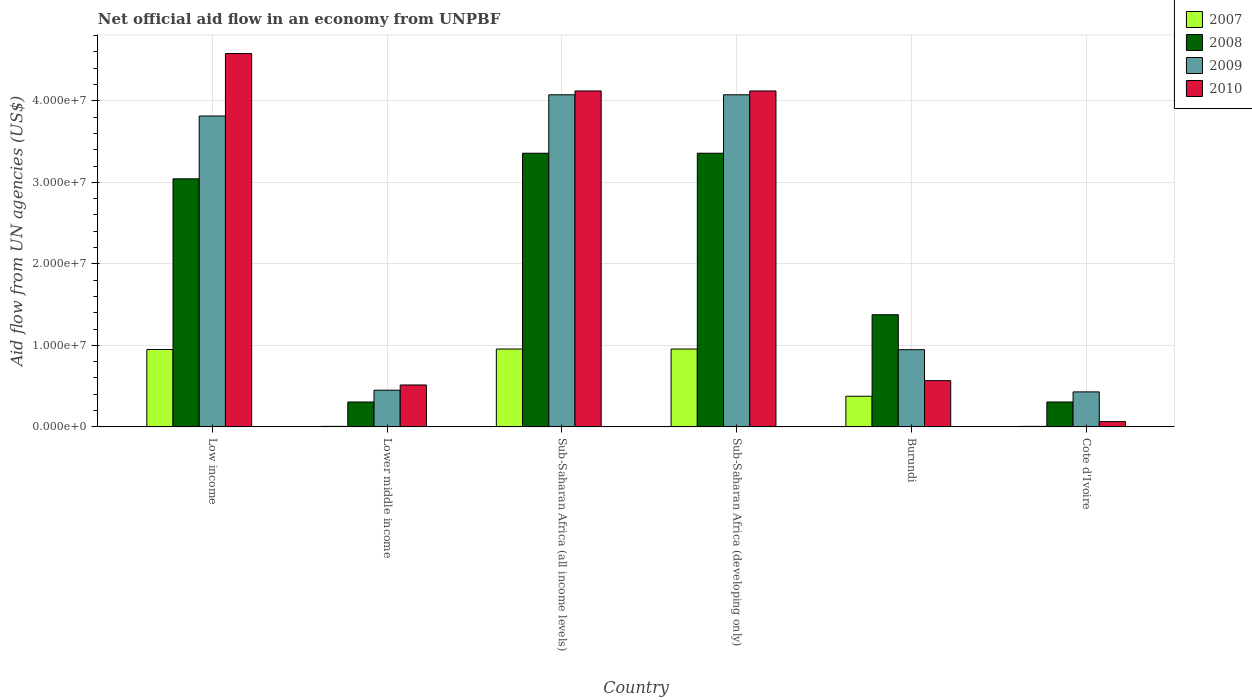How many different coloured bars are there?
Your response must be concise. 4. How many groups of bars are there?
Offer a terse response. 6. What is the label of the 4th group of bars from the left?
Ensure brevity in your answer.  Sub-Saharan Africa (developing only). In how many cases, is the number of bars for a given country not equal to the number of legend labels?
Ensure brevity in your answer.  0. What is the net official aid flow in 2009 in Cote d'Ivoire?
Provide a short and direct response. 4.29e+06. Across all countries, what is the maximum net official aid flow in 2010?
Provide a short and direct response. 4.58e+07. In which country was the net official aid flow in 2009 maximum?
Your answer should be compact. Sub-Saharan Africa (all income levels). In which country was the net official aid flow in 2010 minimum?
Give a very brief answer. Cote d'Ivoire. What is the total net official aid flow in 2010 in the graph?
Your response must be concise. 1.40e+08. What is the difference between the net official aid flow in 2010 in Burundi and that in Sub-Saharan Africa (developing only)?
Keep it short and to the point. -3.55e+07. What is the difference between the net official aid flow in 2009 in Low income and the net official aid flow in 2008 in Sub-Saharan Africa (developing only)?
Give a very brief answer. 4.57e+06. What is the average net official aid flow in 2008 per country?
Make the answer very short. 1.96e+07. What is the difference between the net official aid flow of/in 2008 and net official aid flow of/in 2009 in Cote d'Ivoire?
Make the answer very short. -1.24e+06. In how many countries, is the net official aid flow in 2009 greater than 22000000 US$?
Provide a short and direct response. 3. What is the ratio of the net official aid flow in 2010 in Burundi to that in Sub-Saharan Africa (developing only)?
Your answer should be very brief. 0.14. Is the net official aid flow in 2010 in Cote d'Ivoire less than that in Sub-Saharan Africa (all income levels)?
Give a very brief answer. Yes. What is the difference between the highest and the second highest net official aid flow in 2009?
Offer a very short reply. 2.60e+06. What is the difference between the highest and the lowest net official aid flow in 2009?
Make the answer very short. 3.64e+07. Is the sum of the net official aid flow in 2009 in Low income and Sub-Saharan Africa (developing only) greater than the maximum net official aid flow in 2008 across all countries?
Ensure brevity in your answer.  Yes. What does the 1st bar from the left in Low income represents?
Your response must be concise. 2007. How many bars are there?
Keep it short and to the point. 24. What is the difference between two consecutive major ticks on the Y-axis?
Provide a succinct answer. 1.00e+07. Does the graph contain any zero values?
Your answer should be compact. No. Where does the legend appear in the graph?
Your answer should be compact. Top right. How are the legend labels stacked?
Give a very brief answer. Vertical. What is the title of the graph?
Ensure brevity in your answer.  Net official aid flow in an economy from UNPBF. Does "1962" appear as one of the legend labels in the graph?
Your answer should be compact. No. What is the label or title of the X-axis?
Keep it short and to the point. Country. What is the label or title of the Y-axis?
Make the answer very short. Aid flow from UN agencies (US$). What is the Aid flow from UN agencies (US$) in 2007 in Low income?
Give a very brief answer. 9.49e+06. What is the Aid flow from UN agencies (US$) of 2008 in Low income?
Make the answer very short. 3.04e+07. What is the Aid flow from UN agencies (US$) in 2009 in Low income?
Ensure brevity in your answer.  3.81e+07. What is the Aid flow from UN agencies (US$) of 2010 in Low income?
Provide a short and direct response. 4.58e+07. What is the Aid flow from UN agencies (US$) in 2008 in Lower middle income?
Provide a succinct answer. 3.05e+06. What is the Aid flow from UN agencies (US$) in 2009 in Lower middle income?
Your answer should be very brief. 4.50e+06. What is the Aid flow from UN agencies (US$) of 2010 in Lower middle income?
Give a very brief answer. 5.14e+06. What is the Aid flow from UN agencies (US$) in 2007 in Sub-Saharan Africa (all income levels)?
Offer a terse response. 9.55e+06. What is the Aid flow from UN agencies (US$) in 2008 in Sub-Saharan Africa (all income levels)?
Provide a short and direct response. 3.36e+07. What is the Aid flow from UN agencies (US$) of 2009 in Sub-Saharan Africa (all income levels)?
Offer a terse response. 4.07e+07. What is the Aid flow from UN agencies (US$) in 2010 in Sub-Saharan Africa (all income levels)?
Your answer should be compact. 4.12e+07. What is the Aid flow from UN agencies (US$) in 2007 in Sub-Saharan Africa (developing only)?
Keep it short and to the point. 9.55e+06. What is the Aid flow from UN agencies (US$) of 2008 in Sub-Saharan Africa (developing only)?
Your answer should be compact. 3.36e+07. What is the Aid flow from UN agencies (US$) in 2009 in Sub-Saharan Africa (developing only)?
Your response must be concise. 4.07e+07. What is the Aid flow from UN agencies (US$) of 2010 in Sub-Saharan Africa (developing only)?
Your answer should be very brief. 4.12e+07. What is the Aid flow from UN agencies (US$) in 2007 in Burundi?
Offer a terse response. 3.76e+06. What is the Aid flow from UN agencies (US$) of 2008 in Burundi?
Make the answer very short. 1.38e+07. What is the Aid flow from UN agencies (US$) of 2009 in Burundi?
Provide a short and direct response. 9.47e+06. What is the Aid flow from UN agencies (US$) of 2010 in Burundi?
Offer a terse response. 5.67e+06. What is the Aid flow from UN agencies (US$) in 2008 in Cote d'Ivoire?
Provide a short and direct response. 3.05e+06. What is the Aid flow from UN agencies (US$) of 2009 in Cote d'Ivoire?
Make the answer very short. 4.29e+06. What is the Aid flow from UN agencies (US$) of 2010 in Cote d'Ivoire?
Provide a succinct answer. 6.50e+05. Across all countries, what is the maximum Aid flow from UN agencies (US$) of 2007?
Ensure brevity in your answer.  9.55e+06. Across all countries, what is the maximum Aid flow from UN agencies (US$) in 2008?
Provide a succinct answer. 3.36e+07. Across all countries, what is the maximum Aid flow from UN agencies (US$) in 2009?
Make the answer very short. 4.07e+07. Across all countries, what is the maximum Aid flow from UN agencies (US$) of 2010?
Provide a short and direct response. 4.58e+07. Across all countries, what is the minimum Aid flow from UN agencies (US$) of 2007?
Offer a terse response. 6.00e+04. Across all countries, what is the minimum Aid flow from UN agencies (US$) in 2008?
Offer a terse response. 3.05e+06. Across all countries, what is the minimum Aid flow from UN agencies (US$) of 2009?
Give a very brief answer. 4.29e+06. Across all countries, what is the minimum Aid flow from UN agencies (US$) in 2010?
Ensure brevity in your answer.  6.50e+05. What is the total Aid flow from UN agencies (US$) in 2007 in the graph?
Your response must be concise. 3.25e+07. What is the total Aid flow from UN agencies (US$) in 2008 in the graph?
Provide a short and direct response. 1.17e+08. What is the total Aid flow from UN agencies (US$) of 2009 in the graph?
Your answer should be very brief. 1.38e+08. What is the total Aid flow from UN agencies (US$) in 2010 in the graph?
Keep it short and to the point. 1.40e+08. What is the difference between the Aid flow from UN agencies (US$) of 2007 in Low income and that in Lower middle income?
Make the answer very short. 9.43e+06. What is the difference between the Aid flow from UN agencies (US$) of 2008 in Low income and that in Lower middle income?
Provide a short and direct response. 2.74e+07. What is the difference between the Aid flow from UN agencies (US$) in 2009 in Low income and that in Lower middle income?
Your answer should be compact. 3.36e+07. What is the difference between the Aid flow from UN agencies (US$) in 2010 in Low income and that in Lower middle income?
Provide a succinct answer. 4.07e+07. What is the difference between the Aid flow from UN agencies (US$) of 2008 in Low income and that in Sub-Saharan Africa (all income levels)?
Give a very brief answer. -3.14e+06. What is the difference between the Aid flow from UN agencies (US$) in 2009 in Low income and that in Sub-Saharan Africa (all income levels)?
Your answer should be very brief. -2.60e+06. What is the difference between the Aid flow from UN agencies (US$) of 2010 in Low income and that in Sub-Saharan Africa (all income levels)?
Provide a succinct answer. 4.59e+06. What is the difference between the Aid flow from UN agencies (US$) in 2008 in Low income and that in Sub-Saharan Africa (developing only)?
Make the answer very short. -3.14e+06. What is the difference between the Aid flow from UN agencies (US$) of 2009 in Low income and that in Sub-Saharan Africa (developing only)?
Provide a succinct answer. -2.60e+06. What is the difference between the Aid flow from UN agencies (US$) of 2010 in Low income and that in Sub-Saharan Africa (developing only)?
Keep it short and to the point. 4.59e+06. What is the difference between the Aid flow from UN agencies (US$) of 2007 in Low income and that in Burundi?
Your answer should be very brief. 5.73e+06. What is the difference between the Aid flow from UN agencies (US$) in 2008 in Low income and that in Burundi?
Your answer should be compact. 1.67e+07. What is the difference between the Aid flow from UN agencies (US$) of 2009 in Low income and that in Burundi?
Your answer should be compact. 2.87e+07. What is the difference between the Aid flow from UN agencies (US$) in 2010 in Low income and that in Burundi?
Offer a very short reply. 4.01e+07. What is the difference between the Aid flow from UN agencies (US$) of 2007 in Low income and that in Cote d'Ivoire?
Offer a very short reply. 9.43e+06. What is the difference between the Aid flow from UN agencies (US$) of 2008 in Low income and that in Cote d'Ivoire?
Ensure brevity in your answer.  2.74e+07. What is the difference between the Aid flow from UN agencies (US$) in 2009 in Low income and that in Cote d'Ivoire?
Your answer should be very brief. 3.38e+07. What is the difference between the Aid flow from UN agencies (US$) of 2010 in Low income and that in Cote d'Ivoire?
Make the answer very short. 4.52e+07. What is the difference between the Aid flow from UN agencies (US$) in 2007 in Lower middle income and that in Sub-Saharan Africa (all income levels)?
Offer a very short reply. -9.49e+06. What is the difference between the Aid flow from UN agencies (US$) in 2008 in Lower middle income and that in Sub-Saharan Africa (all income levels)?
Your answer should be compact. -3.05e+07. What is the difference between the Aid flow from UN agencies (US$) in 2009 in Lower middle income and that in Sub-Saharan Africa (all income levels)?
Keep it short and to the point. -3.62e+07. What is the difference between the Aid flow from UN agencies (US$) in 2010 in Lower middle income and that in Sub-Saharan Africa (all income levels)?
Offer a terse response. -3.61e+07. What is the difference between the Aid flow from UN agencies (US$) of 2007 in Lower middle income and that in Sub-Saharan Africa (developing only)?
Keep it short and to the point. -9.49e+06. What is the difference between the Aid flow from UN agencies (US$) in 2008 in Lower middle income and that in Sub-Saharan Africa (developing only)?
Give a very brief answer. -3.05e+07. What is the difference between the Aid flow from UN agencies (US$) of 2009 in Lower middle income and that in Sub-Saharan Africa (developing only)?
Offer a terse response. -3.62e+07. What is the difference between the Aid flow from UN agencies (US$) of 2010 in Lower middle income and that in Sub-Saharan Africa (developing only)?
Provide a short and direct response. -3.61e+07. What is the difference between the Aid flow from UN agencies (US$) of 2007 in Lower middle income and that in Burundi?
Provide a succinct answer. -3.70e+06. What is the difference between the Aid flow from UN agencies (US$) of 2008 in Lower middle income and that in Burundi?
Provide a short and direct response. -1.07e+07. What is the difference between the Aid flow from UN agencies (US$) in 2009 in Lower middle income and that in Burundi?
Make the answer very short. -4.97e+06. What is the difference between the Aid flow from UN agencies (US$) in 2010 in Lower middle income and that in Burundi?
Provide a short and direct response. -5.30e+05. What is the difference between the Aid flow from UN agencies (US$) of 2008 in Lower middle income and that in Cote d'Ivoire?
Make the answer very short. 0. What is the difference between the Aid flow from UN agencies (US$) in 2009 in Lower middle income and that in Cote d'Ivoire?
Provide a succinct answer. 2.10e+05. What is the difference between the Aid flow from UN agencies (US$) in 2010 in Lower middle income and that in Cote d'Ivoire?
Your answer should be compact. 4.49e+06. What is the difference between the Aid flow from UN agencies (US$) of 2007 in Sub-Saharan Africa (all income levels) and that in Sub-Saharan Africa (developing only)?
Offer a very short reply. 0. What is the difference between the Aid flow from UN agencies (US$) in 2008 in Sub-Saharan Africa (all income levels) and that in Sub-Saharan Africa (developing only)?
Offer a terse response. 0. What is the difference between the Aid flow from UN agencies (US$) in 2007 in Sub-Saharan Africa (all income levels) and that in Burundi?
Offer a very short reply. 5.79e+06. What is the difference between the Aid flow from UN agencies (US$) of 2008 in Sub-Saharan Africa (all income levels) and that in Burundi?
Keep it short and to the point. 1.98e+07. What is the difference between the Aid flow from UN agencies (US$) in 2009 in Sub-Saharan Africa (all income levels) and that in Burundi?
Offer a very short reply. 3.13e+07. What is the difference between the Aid flow from UN agencies (US$) of 2010 in Sub-Saharan Africa (all income levels) and that in Burundi?
Your response must be concise. 3.55e+07. What is the difference between the Aid flow from UN agencies (US$) in 2007 in Sub-Saharan Africa (all income levels) and that in Cote d'Ivoire?
Ensure brevity in your answer.  9.49e+06. What is the difference between the Aid flow from UN agencies (US$) of 2008 in Sub-Saharan Africa (all income levels) and that in Cote d'Ivoire?
Provide a short and direct response. 3.05e+07. What is the difference between the Aid flow from UN agencies (US$) in 2009 in Sub-Saharan Africa (all income levels) and that in Cote d'Ivoire?
Provide a short and direct response. 3.64e+07. What is the difference between the Aid flow from UN agencies (US$) in 2010 in Sub-Saharan Africa (all income levels) and that in Cote d'Ivoire?
Your answer should be compact. 4.06e+07. What is the difference between the Aid flow from UN agencies (US$) in 2007 in Sub-Saharan Africa (developing only) and that in Burundi?
Make the answer very short. 5.79e+06. What is the difference between the Aid flow from UN agencies (US$) in 2008 in Sub-Saharan Africa (developing only) and that in Burundi?
Ensure brevity in your answer.  1.98e+07. What is the difference between the Aid flow from UN agencies (US$) in 2009 in Sub-Saharan Africa (developing only) and that in Burundi?
Ensure brevity in your answer.  3.13e+07. What is the difference between the Aid flow from UN agencies (US$) of 2010 in Sub-Saharan Africa (developing only) and that in Burundi?
Your response must be concise. 3.55e+07. What is the difference between the Aid flow from UN agencies (US$) of 2007 in Sub-Saharan Africa (developing only) and that in Cote d'Ivoire?
Give a very brief answer. 9.49e+06. What is the difference between the Aid flow from UN agencies (US$) of 2008 in Sub-Saharan Africa (developing only) and that in Cote d'Ivoire?
Your answer should be compact. 3.05e+07. What is the difference between the Aid flow from UN agencies (US$) of 2009 in Sub-Saharan Africa (developing only) and that in Cote d'Ivoire?
Give a very brief answer. 3.64e+07. What is the difference between the Aid flow from UN agencies (US$) of 2010 in Sub-Saharan Africa (developing only) and that in Cote d'Ivoire?
Ensure brevity in your answer.  4.06e+07. What is the difference between the Aid flow from UN agencies (US$) of 2007 in Burundi and that in Cote d'Ivoire?
Your response must be concise. 3.70e+06. What is the difference between the Aid flow from UN agencies (US$) of 2008 in Burundi and that in Cote d'Ivoire?
Offer a terse response. 1.07e+07. What is the difference between the Aid flow from UN agencies (US$) in 2009 in Burundi and that in Cote d'Ivoire?
Give a very brief answer. 5.18e+06. What is the difference between the Aid flow from UN agencies (US$) in 2010 in Burundi and that in Cote d'Ivoire?
Give a very brief answer. 5.02e+06. What is the difference between the Aid flow from UN agencies (US$) of 2007 in Low income and the Aid flow from UN agencies (US$) of 2008 in Lower middle income?
Provide a short and direct response. 6.44e+06. What is the difference between the Aid flow from UN agencies (US$) in 2007 in Low income and the Aid flow from UN agencies (US$) in 2009 in Lower middle income?
Ensure brevity in your answer.  4.99e+06. What is the difference between the Aid flow from UN agencies (US$) of 2007 in Low income and the Aid flow from UN agencies (US$) of 2010 in Lower middle income?
Your response must be concise. 4.35e+06. What is the difference between the Aid flow from UN agencies (US$) in 2008 in Low income and the Aid flow from UN agencies (US$) in 2009 in Lower middle income?
Your answer should be very brief. 2.59e+07. What is the difference between the Aid flow from UN agencies (US$) of 2008 in Low income and the Aid flow from UN agencies (US$) of 2010 in Lower middle income?
Keep it short and to the point. 2.53e+07. What is the difference between the Aid flow from UN agencies (US$) in 2009 in Low income and the Aid flow from UN agencies (US$) in 2010 in Lower middle income?
Offer a terse response. 3.30e+07. What is the difference between the Aid flow from UN agencies (US$) of 2007 in Low income and the Aid flow from UN agencies (US$) of 2008 in Sub-Saharan Africa (all income levels)?
Offer a terse response. -2.41e+07. What is the difference between the Aid flow from UN agencies (US$) of 2007 in Low income and the Aid flow from UN agencies (US$) of 2009 in Sub-Saharan Africa (all income levels)?
Your response must be concise. -3.12e+07. What is the difference between the Aid flow from UN agencies (US$) of 2007 in Low income and the Aid flow from UN agencies (US$) of 2010 in Sub-Saharan Africa (all income levels)?
Your answer should be very brief. -3.17e+07. What is the difference between the Aid flow from UN agencies (US$) in 2008 in Low income and the Aid flow from UN agencies (US$) in 2009 in Sub-Saharan Africa (all income levels)?
Provide a short and direct response. -1.03e+07. What is the difference between the Aid flow from UN agencies (US$) of 2008 in Low income and the Aid flow from UN agencies (US$) of 2010 in Sub-Saharan Africa (all income levels)?
Offer a very short reply. -1.08e+07. What is the difference between the Aid flow from UN agencies (US$) of 2009 in Low income and the Aid flow from UN agencies (US$) of 2010 in Sub-Saharan Africa (all income levels)?
Keep it short and to the point. -3.07e+06. What is the difference between the Aid flow from UN agencies (US$) of 2007 in Low income and the Aid flow from UN agencies (US$) of 2008 in Sub-Saharan Africa (developing only)?
Ensure brevity in your answer.  -2.41e+07. What is the difference between the Aid flow from UN agencies (US$) of 2007 in Low income and the Aid flow from UN agencies (US$) of 2009 in Sub-Saharan Africa (developing only)?
Provide a short and direct response. -3.12e+07. What is the difference between the Aid flow from UN agencies (US$) of 2007 in Low income and the Aid flow from UN agencies (US$) of 2010 in Sub-Saharan Africa (developing only)?
Offer a terse response. -3.17e+07. What is the difference between the Aid flow from UN agencies (US$) of 2008 in Low income and the Aid flow from UN agencies (US$) of 2009 in Sub-Saharan Africa (developing only)?
Your response must be concise. -1.03e+07. What is the difference between the Aid flow from UN agencies (US$) of 2008 in Low income and the Aid flow from UN agencies (US$) of 2010 in Sub-Saharan Africa (developing only)?
Your answer should be compact. -1.08e+07. What is the difference between the Aid flow from UN agencies (US$) in 2009 in Low income and the Aid flow from UN agencies (US$) in 2010 in Sub-Saharan Africa (developing only)?
Offer a very short reply. -3.07e+06. What is the difference between the Aid flow from UN agencies (US$) in 2007 in Low income and the Aid flow from UN agencies (US$) in 2008 in Burundi?
Offer a terse response. -4.27e+06. What is the difference between the Aid flow from UN agencies (US$) of 2007 in Low income and the Aid flow from UN agencies (US$) of 2009 in Burundi?
Provide a succinct answer. 2.00e+04. What is the difference between the Aid flow from UN agencies (US$) of 2007 in Low income and the Aid flow from UN agencies (US$) of 2010 in Burundi?
Ensure brevity in your answer.  3.82e+06. What is the difference between the Aid flow from UN agencies (US$) of 2008 in Low income and the Aid flow from UN agencies (US$) of 2009 in Burundi?
Offer a very short reply. 2.10e+07. What is the difference between the Aid flow from UN agencies (US$) of 2008 in Low income and the Aid flow from UN agencies (US$) of 2010 in Burundi?
Your response must be concise. 2.48e+07. What is the difference between the Aid flow from UN agencies (US$) in 2009 in Low income and the Aid flow from UN agencies (US$) in 2010 in Burundi?
Make the answer very short. 3.25e+07. What is the difference between the Aid flow from UN agencies (US$) of 2007 in Low income and the Aid flow from UN agencies (US$) of 2008 in Cote d'Ivoire?
Keep it short and to the point. 6.44e+06. What is the difference between the Aid flow from UN agencies (US$) in 2007 in Low income and the Aid flow from UN agencies (US$) in 2009 in Cote d'Ivoire?
Your response must be concise. 5.20e+06. What is the difference between the Aid flow from UN agencies (US$) in 2007 in Low income and the Aid flow from UN agencies (US$) in 2010 in Cote d'Ivoire?
Offer a terse response. 8.84e+06. What is the difference between the Aid flow from UN agencies (US$) of 2008 in Low income and the Aid flow from UN agencies (US$) of 2009 in Cote d'Ivoire?
Offer a terse response. 2.61e+07. What is the difference between the Aid flow from UN agencies (US$) in 2008 in Low income and the Aid flow from UN agencies (US$) in 2010 in Cote d'Ivoire?
Ensure brevity in your answer.  2.98e+07. What is the difference between the Aid flow from UN agencies (US$) of 2009 in Low income and the Aid flow from UN agencies (US$) of 2010 in Cote d'Ivoire?
Give a very brief answer. 3.75e+07. What is the difference between the Aid flow from UN agencies (US$) in 2007 in Lower middle income and the Aid flow from UN agencies (US$) in 2008 in Sub-Saharan Africa (all income levels)?
Your response must be concise. -3.35e+07. What is the difference between the Aid flow from UN agencies (US$) of 2007 in Lower middle income and the Aid flow from UN agencies (US$) of 2009 in Sub-Saharan Africa (all income levels)?
Give a very brief answer. -4.07e+07. What is the difference between the Aid flow from UN agencies (US$) in 2007 in Lower middle income and the Aid flow from UN agencies (US$) in 2010 in Sub-Saharan Africa (all income levels)?
Provide a succinct answer. -4.12e+07. What is the difference between the Aid flow from UN agencies (US$) in 2008 in Lower middle income and the Aid flow from UN agencies (US$) in 2009 in Sub-Saharan Africa (all income levels)?
Your response must be concise. -3.77e+07. What is the difference between the Aid flow from UN agencies (US$) in 2008 in Lower middle income and the Aid flow from UN agencies (US$) in 2010 in Sub-Saharan Africa (all income levels)?
Your answer should be very brief. -3.82e+07. What is the difference between the Aid flow from UN agencies (US$) of 2009 in Lower middle income and the Aid flow from UN agencies (US$) of 2010 in Sub-Saharan Africa (all income levels)?
Keep it short and to the point. -3.67e+07. What is the difference between the Aid flow from UN agencies (US$) in 2007 in Lower middle income and the Aid flow from UN agencies (US$) in 2008 in Sub-Saharan Africa (developing only)?
Keep it short and to the point. -3.35e+07. What is the difference between the Aid flow from UN agencies (US$) of 2007 in Lower middle income and the Aid flow from UN agencies (US$) of 2009 in Sub-Saharan Africa (developing only)?
Offer a terse response. -4.07e+07. What is the difference between the Aid flow from UN agencies (US$) in 2007 in Lower middle income and the Aid flow from UN agencies (US$) in 2010 in Sub-Saharan Africa (developing only)?
Provide a succinct answer. -4.12e+07. What is the difference between the Aid flow from UN agencies (US$) of 2008 in Lower middle income and the Aid flow from UN agencies (US$) of 2009 in Sub-Saharan Africa (developing only)?
Provide a short and direct response. -3.77e+07. What is the difference between the Aid flow from UN agencies (US$) of 2008 in Lower middle income and the Aid flow from UN agencies (US$) of 2010 in Sub-Saharan Africa (developing only)?
Give a very brief answer. -3.82e+07. What is the difference between the Aid flow from UN agencies (US$) in 2009 in Lower middle income and the Aid flow from UN agencies (US$) in 2010 in Sub-Saharan Africa (developing only)?
Ensure brevity in your answer.  -3.67e+07. What is the difference between the Aid flow from UN agencies (US$) in 2007 in Lower middle income and the Aid flow from UN agencies (US$) in 2008 in Burundi?
Your response must be concise. -1.37e+07. What is the difference between the Aid flow from UN agencies (US$) of 2007 in Lower middle income and the Aid flow from UN agencies (US$) of 2009 in Burundi?
Your answer should be compact. -9.41e+06. What is the difference between the Aid flow from UN agencies (US$) in 2007 in Lower middle income and the Aid flow from UN agencies (US$) in 2010 in Burundi?
Keep it short and to the point. -5.61e+06. What is the difference between the Aid flow from UN agencies (US$) in 2008 in Lower middle income and the Aid flow from UN agencies (US$) in 2009 in Burundi?
Offer a terse response. -6.42e+06. What is the difference between the Aid flow from UN agencies (US$) of 2008 in Lower middle income and the Aid flow from UN agencies (US$) of 2010 in Burundi?
Provide a succinct answer. -2.62e+06. What is the difference between the Aid flow from UN agencies (US$) of 2009 in Lower middle income and the Aid flow from UN agencies (US$) of 2010 in Burundi?
Make the answer very short. -1.17e+06. What is the difference between the Aid flow from UN agencies (US$) of 2007 in Lower middle income and the Aid flow from UN agencies (US$) of 2008 in Cote d'Ivoire?
Your response must be concise. -2.99e+06. What is the difference between the Aid flow from UN agencies (US$) in 2007 in Lower middle income and the Aid flow from UN agencies (US$) in 2009 in Cote d'Ivoire?
Provide a short and direct response. -4.23e+06. What is the difference between the Aid flow from UN agencies (US$) of 2007 in Lower middle income and the Aid flow from UN agencies (US$) of 2010 in Cote d'Ivoire?
Keep it short and to the point. -5.90e+05. What is the difference between the Aid flow from UN agencies (US$) of 2008 in Lower middle income and the Aid flow from UN agencies (US$) of 2009 in Cote d'Ivoire?
Give a very brief answer. -1.24e+06. What is the difference between the Aid flow from UN agencies (US$) in 2008 in Lower middle income and the Aid flow from UN agencies (US$) in 2010 in Cote d'Ivoire?
Ensure brevity in your answer.  2.40e+06. What is the difference between the Aid flow from UN agencies (US$) in 2009 in Lower middle income and the Aid flow from UN agencies (US$) in 2010 in Cote d'Ivoire?
Ensure brevity in your answer.  3.85e+06. What is the difference between the Aid flow from UN agencies (US$) of 2007 in Sub-Saharan Africa (all income levels) and the Aid flow from UN agencies (US$) of 2008 in Sub-Saharan Africa (developing only)?
Make the answer very short. -2.40e+07. What is the difference between the Aid flow from UN agencies (US$) in 2007 in Sub-Saharan Africa (all income levels) and the Aid flow from UN agencies (US$) in 2009 in Sub-Saharan Africa (developing only)?
Offer a very short reply. -3.12e+07. What is the difference between the Aid flow from UN agencies (US$) of 2007 in Sub-Saharan Africa (all income levels) and the Aid flow from UN agencies (US$) of 2010 in Sub-Saharan Africa (developing only)?
Make the answer very short. -3.17e+07. What is the difference between the Aid flow from UN agencies (US$) of 2008 in Sub-Saharan Africa (all income levels) and the Aid flow from UN agencies (US$) of 2009 in Sub-Saharan Africa (developing only)?
Provide a short and direct response. -7.17e+06. What is the difference between the Aid flow from UN agencies (US$) of 2008 in Sub-Saharan Africa (all income levels) and the Aid flow from UN agencies (US$) of 2010 in Sub-Saharan Africa (developing only)?
Make the answer very short. -7.64e+06. What is the difference between the Aid flow from UN agencies (US$) in 2009 in Sub-Saharan Africa (all income levels) and the Aid flow from UN agencies (US$) in 2010 in Sub-Saharan Africa (developing only)?
Provide a succinct answer. -4.70e+05. What is the difference between the Aid flow from UN agencies (US$) in 2007 in Sub-Saharan Africa (all income levels) and the Aid flow from UN agencies (US$) in 2008 in Burundi?
Your answer should be very brief. -4.21e+06. What is the difference between the Aid flow from UN agencies (US$) of 2007 in Sub-Saharan Africa (all income levels) and the Aid flow from UN agencies (US$) of 2009 in Burundi?
Your answer should be very brief. 8.00e+04. What is the difference between the Aid flow from UN agencies (US$) in 2007 in Sub-Saharan Africa (all income levels) and the Aid flow from UN agencies (US$) in 2010 in Burundi?
Provide a short and direct response. 3.88e+06. What is the difference between the Aid flow from UN agencies (US$) of 2008 in Sub-Saharan Africa (all income levels) and the Aid flow from UN agencies (US$) of 2009 in Burundi?
Your response must be concise. 2.41e+07. What is the difference between the Aid flow from UN agencies (US$) of 2008 in Sub-Saharan Africa (all income levels) and the Aid flow from UN agencies (US$) of 2010 in Burundi?
Keep it short and to the point. 2.79e+07. What is the difference between the Aid flow from UN agencies (US$) in 2009 in Sub-Saharan Africa (all income levels) and the Aid flow from UN agencies (US$) in 2010 in Burundi?
Give a very brief answer. 3.51e+07. What is the difference between the Aid flow from UN agencies (US$) in 2007 in Sub-Saharan Africa (all income levels) and the Aid flow from UN agencies (US$) in 2008 in Cote d'Ivoire?
Offer a terse response. 6.50e+06. What is the difference between the Aid flow from UN agencies (US$) of 2007 in Sub-Saharan Africa (all income levels) and the Aid flow from UN agencies (US$) of 2009 in Cote d'Ivoire?
Give a very brief answer. 5.26e+06. What is the difference between the Aid flow from UN agencies (US$) of 2007 in Sub-Saharan Africa (all income levels) and the Aid flow from UN agencies (US$) of 2010 in Cote d'Ivoire?
Your answer should be compact. 8.90e+06. What is the difference between the Aid flow from UN agencies (US$) of 2008 in Sub-Saharan Africa (all income levels) and the Aid flow from UN agencies (US$) of 2009 in Cote d'Ivoire?
Offer a very short reply. 2.93e+07. What is the difference between the Aid flow from UN agencies (US$) of 2008 in Sub-Saharan Africa (all income levels) and the Aid flow from UN agencies (US$) of 2010 in Cote d'Ivoire?
Offer a very short reply. 3.29e+07. What is the difference between the Aid flow from UN agencies (US$) in 2009 in Sub-Saharan Africa (all income levels) and the Aid flow from UN agencies (US$) in 2010 in Cote d'Ivoire?
Offer a terse response. 4.01e+07. What is the difference between the Aid flow from UN agencies (US$) of 2007 in Sub-Saharan Africa (developing only) and the Aid flow from UN agencies (US$) of 2008 in Burundi?
Provide a short and direct response. -4.21e+06. What is the difference between the Aid flow from UN agencies (US$) of 2007 in Sub-Saharan Africa (developing only) and the Aid flow from UN agencies (US$) of 2009 in Burundi?
Ensure brevity in your answer.  8.00e+04. What is the difference between the Aid flow from UN agencies (US$) of 2007 in Sub-Saharan Africa (developing only) and the Aid flow from UN agencies (US$) of 2010 in Burundi?
Your answer should be compact. 3.88e+06. What is the difference between the Aid flow from UN agencies (US$) in 2008 in Sub-Saharan Africa (developing only) and the Aid flow from UN agencies (US$) in 2009 in Burundi?
Offer a very short reply. 2.41e+07. What is the difference between the Aid flow from UN agencies (US$) in 2008 in Sub-Saharan Africa (developing only) and the Aid flow from UN agencies (US$) in 2010 in Burundi?
Your answer should be very brief. 2.79e+07. What is the difference between the Aid flow from UN agencies (US$) in 2009 in Sub-Saharan Africa (developing only) and the Aid flow from UN agencies (US$) in 2010 in Burundi?
Offer a terse response. 3.51e+07. What is the difference between the Aid flow from UN agencies (US$) in 2007 in Sub-Saharan Africa (developing only) and the Aid flow from UN agencies (US$) in 2008 in Cote d'Ivoire?
Your answer should be very brief. 6.50e+06. What is the difference between the Aid flow from UN agencies (US$) in 2007 in Sub-Saharan Africa (developing only) and the Aid flow from UN agencies (US$) in 2009 in Cote d'Ivoire?
Offer a terse response. 5.26e+06. What is the difference between the Aid flow from UN agencies (US$) in 2007 in Sub-Saharan Africa (developing only) and the Aid flow from UN agencies (US$) in 2010 in Cote d'Ivoire?
Provide a succinct answer. 8.90e+06. What is the difference between the Aid flow from UN agencies (US$) of 2008 in Sub-Saharan Africa (developing only) and the Aid flow from UN agencies (US$) of 2009 in Cote d'Ivoire?
Provide a short and direct response. 2.93e+07. What is the difference between the Aid flow from UN agencies (US$) of 2008 in Sub-Saharan Africa (developing only) and the Aid flow from UN agencies (US$) of 2010 in Cote d'Ivoire?
Keep it short and to the point. 3.29e+07. What is the difference between the Aid flow from UN agencies (US$) of 2009 in Sub-Saharan Africa (developing only) and the Aid flow from UN agencies (US$) of 2010 in Cote d'Ivoire?
Make the answer very short. 4.01e+07. What is the difference between the Aid flow from UN agencies (US$) of 2007 in Burundi and the Aid flow from UN agencies (US$) of 2008 in Cote d'Ivoire?
Provide a succinct answer. 7.10e+05. What is the difference between the Aid flow from UN agencies (US$) in 2007 in Burundi and the Aid flow from UN agencies (US$) in 2009 in Cote d'Ivoire?
Make the answer very short. -5.30e+05. What is the difference between the Aid flow from UN agencies (US$) of 2007 in Burundi and the Aid flow from UN agencies (US$) of 2010 in Cote d'Ivoire?
Your answer should be very brief. 3.11e+06. What is the difference between the Aid flow from UN agencies (US$) in 2008 in Burundi and the Aid flow from UN agencies (US$) in 2009 in Cote d'Ivoire?
Give a very brief answer. 9.47e+06. What is the difference between the Aid flow from UN agencies (US$) in 2008 in Burundi and the Aid flow from UN agencies (US$) in 2010 in Cote d'Ivoire?
Offer a very short reply. 1.31e+07. What is the difference between the Aid flow from UN agencies (US$) in 2009 in Burundi and the Aid flow from UN agencies (US$) in 2010 in Cote d'Ivoire?
Give a very brief answer. 8.82e+06. What is the average Aid flow from UN agencies (US$) of 2007 per country?
Provide a short and direct response. 5.41e+06. What is the average Aid flow from UN agencies (US$) in 2008 per country?
Your answer should be very brief. 1.96e+07. What is the average Aid flow from UN agencies (US$) of 2009 per country?
Give a very brief answer. 2.30e+07. What is the average Aid flow from UN agencies (US$) in 2010 per country?
Ensure brevity in your answer.  2.33e+07. What is the difference between the Aid flow from UN agencies (US$) in 2007 and Aid flow from UN agencies (US$) in 2008 in Low income?
Provide a succinct answer. -2.09e+07. What is the difference between the Aid flow from UN agencies (US$) in 2007 and Aid flow from UN agencies (US$) in 2009 in Low income?
Your answer should be compact. -2.86e+07. What is the difference between the Aid flow from UN agencies (US$) in 2007 and Aid flow from UN agencies (US$) in 2010 in Low income?
Offer a very short reply. -3.63e+07. What is the difference between the Aid flow from UN agencies (US$) in 2008 and Aid flow from UN agencies (US$) in 2009 in Low income?
Provide a succinct answer. -7.71e+06. What is the difference between the Aid flow from UN agencies (US$) of 2008 and Aid flow from UN agencies (US$) of 2010 in Low income?
Keep it short and to the point. -1.54e+07. What is the difference between the Aid flow from UN agencies (US$) in 2009 and Aid flow from UN agencies (US$) in 2010 in Low income?
Offer a very short reply. -7.66e+06. What is the difference between the Aid flow from UN agencies (US$) of 2007 and Aid flow from UN agencies (US$) of 2008 in Lower middle income?
Give a very brief answer. -2.99e+06. What is the difference between the Aid flow from UN agencies (US$) of 2007 and Aid flow from UN agencies (US$) of 2009 in Lower middle income?
Keep it short and to the point. -4.44e+06. What is the difference between the Aid flow from UN agencies (US$) of 2007 and Aid flow from UN agencies (US$) of 2010 in Lower middle income?
Your answer should be very brief. -5.08e+06. What is the difference between the Aid flow from UN agencies (US$) in 2008 and Aid flow from UN agencies (US$) in 2009 in Lower middle income?
Provide a succinct answer. -1.45e+06. What is the difference between the Aid flow from UN agencies (US$) in 2008 and Aid flow from UN agencies (US$) in 2010 in Lower middle income?
Keep it short and to the point. -2.09e+06. What is the difference between the Aid flow from UN agencies (US$) in 2009 and Aid flow from UN agencies (US$) in 2010 in Lower middle income?
Provide a succinct answer. -6.40e+05. What is the difference between the Aid flow from UN agencies (US$) in 2007 and Aid flow from UN agencies (US$) in 2008 in Sub-Saharan Africa (all income levels)?
Offer a terse response. -2.40e+07. What is the difference between the Aid flow from UN agencies (US$) in 2007 and Aid flow from UN agencies (US$) in 2009 in Sub-Saharan Africa (all income levels)?
Offer a terse response. -3.12e+07. What is the difference between the Aid flow from UN agencies (US$) of 2007 and Aid flow from UN agencies (US$) of 2010 in Sub-Saharan Africa (all income levels)?
Make the answer very short. -3.17e+07. What is the difference between the Aid flow from UN agencies (US$) in 2008 and Aid flow from UN agencies (US$) in 2009 in Sub-Saharan Africa (all income levels)?
Your response must be concise. -7.17e+06. What is the difference between the Aid flow from UN agencies (US$) in 2008 and Aid flow from UN agencies (US$) in 2010 in Sub-Saharan Africa (all income levels)?
Keep it short and to the point. -7.64e+06. What is the difference between the Aid flow from UN agencies (US$) in 2009 and Aid flow from UN agencies (US$) in 2010 in Sub-Saharan Africa (all income levels)?
Make the answer very short. -4.70e+05. What is the difference between the Aid flow from UN agencies (US$) of 2007 and Aid flow from UN agencies (US$) of 2008 in Sub-Saharan Africa (developing only)?
Provide a short and direct response. -2.40e+07. What is the difference between the Aid flow from UN agencies (US$) in 2007 and Aid flow from UN agencies (US$) in 2009 in Sub-Saharan Africa (developing only)?
Your response must be concise. -3.12e+07. What is the difference between the Aid flow from UN agencies (US$) in 2007 and Aid flow from UN agencies (US$) in 2010 in Sub-Saharan Africa (developing only)?
Keep it short and to the point. -3.17e+07. What is the difference between the Aid flow from UN agencies (US$) of 2008 and Aid flow from UN agencies (US$) of 2009 in Sub-Saharan Africa (developing only)?
Your response must be concise. -7.17e+06. What is the difference between the Aid flow from UN agencies (US$) of 2008 and Aid flow from UN agencies (US$) of 2010 in Sub-Saharan Africa (developing only)?
Offer a terse response. -7.64e+06. What is the difference between the Aid flow from UN agencies (US$) of 2009 and Aid flow from UN agencies (US$) of 2010 in Sub-Saharan Africa (developing only)?
Provide a short and direct response. -4.70e+05. What is the difference between the Aid flow from UN agencies (US$) of 2007 and Aid flow from UN agencies (US$) of 2008 in Burundi?
Ensure brevity in your answer.  -1.00e+07. What is the difference between the Aid flow from UN agencies (US$) of 2007 and Aid flow from UN agencies (US$) of 2009 in Burundi?
Provide a short and direct response. -5.71e+06. What is the difference between the Aid flow from UN agencies (US$) of 2007 and Aid flow from UN agencies (US$) of 2010 in Burundi?
Provide a succinct answer. -1.91e+06. What is the difference between the Aid flow from UN agencies (US$) of 2008 and Aid flow from UN agencies (US$) of 2009 in Burundi?
Offer a very short reply. 4.29e+06. What is the difference between the Aid flow from UN agencies (US$) in 2008 and Aid flow from UN agencies (US$) in 2010 in Burundi?
Give a very brief answer. 8.09e+06. What is the difference between the Aid flow from UN agencies (US$) in 2009 and Aid flow from UN agencies (US$) in 2010 in Burundi?
Your answer should be compact. 3.80e+06. What is the difference between the Aid flow from UN agencies (US$) in 2007 and Aid flow from UN agencies (US$) in 2008 in Cote d'Ivoire?
Your answer should be very brief. -2.99e+06. What is the difference between the Aid flow from UN agencies (US$) of 2007 and Aid flow from UN agencies (US$) of 2009 in Cote d'Ivoire?
Provide a succinct answer. -4.23e+06. What is the difference between the Aid flow from UN agencies (US$) in 2007 and Aid flow from UN agencies (US$) in 2010 in Cote d'Ivoire?
Keep it short and to the point. -5.90e+05. What is the difference between the Aid flow from UN agencies (US$) of 2008 and Aid flow from UN agencies (US$) of 2009 in Cote d'Ivoire?
Offer a very short reply. -1.24e+06. What is the difference between the Aid flow from UN agencies (US$) of 2008 and Aid flow from UN agencies (US$) of 2010 in Cote d'Ivoire?
Ensure brevity in your answer.  2.40e+06. What is the difference between the Aid flow from UN agencies (US$) of 2009 and Aid flow from UN agencies (US$) of 2010 in Cote d'Ivoire?
Give a very brief answer. 3.64e+06. What is the ratio of the Aid flow from UN agencies (US$) in 2007 in Low income to that in Lower middle income?
Provide a succinct answer. 158.17. What is the ratio of the Aid flow from UN agencies (US$) of 2008 in Low income to that in Lower middle income?
Make the answer very short. 9.98. What is the ratio of the Aid flow from UN agencies (US$) in 2009 in Low income to that in Lower middle income?
Your answer should be very brief. 8.48. What is the ratio of the Aid flow from UN agencies (US$) of 2010 in Low income to that in Lower middle income?
Keep it short and to the point. 8.91. What is the ratio of the Aid flow from UN agencies (US$) of 2008 in Low income to that in Sub-Saharan Africa (all income levels)?
Your response must be concise. 0.91. What is the ratio of the Aid flow from UN agencies (US$) of 2009 in Low income to that in Sub-Saharan Africa (all income levels)?
Ensure brevity in your answer.  0.94. What is the ratio of the Aid flow from UN agencies (US$) in 2010 in Low income to that in Sub-Saharan Africa (all income levels)?
Offer a very short reply. 1.11. What is the ratio of the Aid flow from UN agencies (US$) in 2008 in Low income to that in Sub-Saharan Africa (developing only)?
Offer a terse response. 0.91. What is the ratio of the Aid flow from UN agencies (US$) of 2009 in Low income to that in Sub-Saharan Africa (developing only)?
Make the answer very short. 0.94. What is the ratio of the Aid flow from UN agencies (US$) of 2010 in Low income to that in Sub-Saharan Africa (developing only)?
Offer a terse response. 1.11. What is the ratio of the Aid flow from UN agencies (US$) in 2007 in Low income to that in Burundi?
Your response must be concise. 2.52. What is the ratio of the Aid flow from UN agencies (US$) of 2008 in Low income to that in Burundi?
Provide a short and direct response. 2.21. What is the ratio of the Aid flow from UN agencies (US$) of 2009 in Low income to that in Burundi?
Offer a very short reply. 4.03. What is the ratio of the Aid flow from UN agencies (US$) in 2010 in Low income to that in Burundi?
Your response must be concise. 8.08. What is the ratio of the Aid flow from UN agencies (US$) in 2007 in Low income to that in Cote d'Ivoire?
Your answer should be very brief. 158.17. What is the ratio of the Aid flow from UN agencies (US$) of 2008 in Low income to that in Cote d'Ivoire?
Give a very brief answer. 9.98. What is the ratio of the Aid flow from UN agencies (US$) of 2009 in Low income to that in Cote d'Ivoire?
Offer a very short reply. 8.89. What is the ratio of the Aid flow from UN agencies (US$) of 2010 in Low income to that in Cote d'Ivoire?
Give a very brief answer. 70.46. What is the ratio of the Aid flow from UN agencies (US$) in 2007 in Lower middle income to that in Sub-Saharan Africa (all income levels)?
Ensure brevity in your answer.  0.01. What is the ratio of the Aid flow from UN agencies (US$) of 2008 in Lower middle income to that in Sub-Saharan Africa (all income levels)?
Provide a succinct answer. 0.09. What is the ratio of the Aid flow from UN agencies (US$) of 2009 in Lower middle income to that in Sub-Saharan Africa (all income levels)?
Your answer should be very brief. 0.11. What is the ratio of the Aid flow from UN agencies (US$) in 2010 in Lower middle income to that in Sub-Saharan Africa (all income levels)?
Provide a succinct answer. 0.12. What is the ratio of the Aid flow from UN agencies (US$) of 2007 in Lower middle income to that in Sub-Saharan Africa (developing only)?
Offer a very short reply. 0.01. What is the ratio of the Aid flow from UN agencies (US$) in 2008 in Lower middle income to that in Sub-Saharan Africa (developing only)?
Provide a short and direct response. 0.09. What is the ratio of the Aid flow from UN agencies (US$) in 2009 in Lower middle income to that in Sub-Saharan Africa (developing only)?
Provide a short and direct response. 0.11. What is the ratio of the Aid flow from UN agencies (US$) in 2010 in Lower middle income to that in Sub-Saharan Africa (developing only)?
Provide a short and direct response. 0.12. What is the ratio of the Aid flow from UN agencies (US$) of 2007 in Lower middle income to that in Burundi?
Ensure brevity in your answer.  0.02. What is the ratio of the Aid flow from UN agencies (US$) of 2008 in Lower middle income to that in Burundi?
Ensure brevity in your answer.  0.22. What is the ratio of the Aid flow from UN agencies (US$) in 2009 in Lower middle income to that in Burundi?
Provide a short and direct response. 0.48. What is the ratio of the Aid flow from UN agencies (US$) of 2010 in Lower middle income to that in Burundi?
Keep it short and to the point. 0.91. What is the ratio of the Aid flow from UN agencies (US$) of 2007 in Lower middle income to that in Cote d'Ivoire?
Make the answer very short. 1. What is the ratio of the Aid flow from UN agencies (US$) in 2008 in Lower middle income to that in Cote d'Ivoire?
Make the answer very short. 1. What is the ratio of the Aid flow from UN agencies (US$) in 2009 in Lower middle income to that in Cote d'Ivoire?
Your response must be concise. 1.05. What is the ratio of the Aid flow from UN agencies (US$) of 2010 in Lower middle income to that in Cote d'Ivoire?
Make the answer very short. 7.91. What is the ratio of the Aid flow from UN agencies (US$) in 2008 in Sub-Saharan Africa (all income levels) to that in Sub-Saharan Africa (developing only)?
Your answer should be very brief. 1. What is the ratio of the Aid flow from UN agencies (US$) of 2009 in Sub-Saharan Africa (all income levels) to that in Sub-Saharan Africa (developing only)?
Offer a terse response. 1. What is the ratio of the Aid flow from UN agencies (US$) in 2007 in Sub-Saharan Africa (all income levels) to that in Burundi?
Your answer should be compact. 2.54. What is the ratio of the Aid flow from UN agencies (US$) in 2008 in Sub-Saharan Africa (all income levels) to that in Burundi?
Your answer should be very brief. 2.44. What is the ratio of the Aid flow from UN agencies (US$) in 2009 in Sub-Saharan Africa (all income levels) to that in Burundi?
Your answer should be compact. 4.3. What is the ratio of the Aid flow from UN agencies (US$) of 2010 in Sub-Saharan Africa (all income levels) to that in Burundi?
Provide a short and direct response. 7.27. What is the ratio of the Aid flow from UN agencies (US$) in 2007 in Sub-Saharan Africa (all income levels) to that in Cote d'Ivoire?
Make the answer very short. 159.17. What is the ratio of the Aid flow from UN agencies (US$) of 2008 in Sub-Saharan Africa (all income levels) to that in Cote d'Ivoire?
Keep it short and to the point. 11.01. What is the ratio of the Aid flow from UN agencies (US$) of 2009 in Sub-Saharan Africa (all income levels) to that in Cote d'Ivoire?
Keep it short and to the point. 9.5. What is the ratio of the Aid flow from UN agencies (US$) in 2010 in Sub-Saharan Africa (all income levels) to that in Cote d'Ivoire?
Make the answer very short. 63.4. What is the ratio of the Aid flow from UN agencies (US$) in 2007 in Sub-Saharan Africa (developing only) to that in Burundi?
Ensure brevity in your answer.  2.54. What is the ratio of the Aid flow from UN agencies (US$) in 2008 in Sub-Saharan Africa (developing only) to that in Burundi?
Give a very brief answer. 2.44. What is the ratio of the Aid flow from UN agencies (US$) in 2009 in Sub-Saharan Africa (developing only) to that in Burundi?
Keep it short and to the point. 4.3. What is the ratio of the Aid flow from UN agencies (US$) of 2010 in Sub-Saharan Africa (developing only) to that in Burundi?
Keep it short and to the point. 7.27. What is the ratio of the Aid flow from UN agencies (US$) of 2007 in Sub-Saharan Africa (developing only) to that in Cote d'Ivoire?
Ensure brevity in your answer.  159.17. What is the ratio of the Aid flow from UN agencies (US$) of 2008 in Sub-Saharan Africa (developing only) to that in Cote d'Ivoire?
Provide a short and direct response. 11.01. What is the ratio of the Aid flow from UN agencies (US$) in 2009 in Sub-Saharan Africa (developing only) to that in Cote d'Ivoire?
Your answer should be very brief. 9.5. What is the ratio of the Aid flow from UN agencies (US$) of 2010 in Sub-Saharan Africa (developing only) to that in Cote d'Ivoire?
Offer a terse response. 63.4. What is the ratio of the Aid flow from UN agencies (US$) in 2007 in Burundi to that in Cote d'Ivoire?
Give a very brief answer. 62.67. What is the ratio of the Aid flow from UN agencies (US$) in 2008 in Burundi to that in Cote d'Ivoire?
Offer a very short reply. 4.51. What is the ratio of the Aid flow from UN agencies (US$) in 2009 in Burundi to that in Cote d'Ivoire?
Ensure brevity in your answer.  2.21. What is the ratio of the Aid flow from UN agencies (US$) in 2010 in Burundi to that in Cote d'Ivoire?
Your answer should be compact. 8.72. What is the difference between the highest and the second highest Aid flow from UN agencies (US$) in 2008?
Your answer should be compact. 0. What is the difference between the highest and the second highest Aid flow from UN agencies (US$) in 2010?
Offer a terse response. 4.59e+06. What is the difference between the highest and the lowest Aid flow from UN agencies (US$) of 2007?
Provide a short and direct response. 9.49e+06. What is the difference between the highest and the lowest Aid flow from UN agencies (US$) of 2008?
Your response must be concise. 3.05e+07. What is the difference between the highest and the lowest Aid flow from UN agencies (US$) of 2009?
Offer a terse response. 3.64e+07. What is the difference between the highest and the lowest Aid flow from UN agencies (US$) of 2010?
Give a very brief answer. 4.52e+07. 